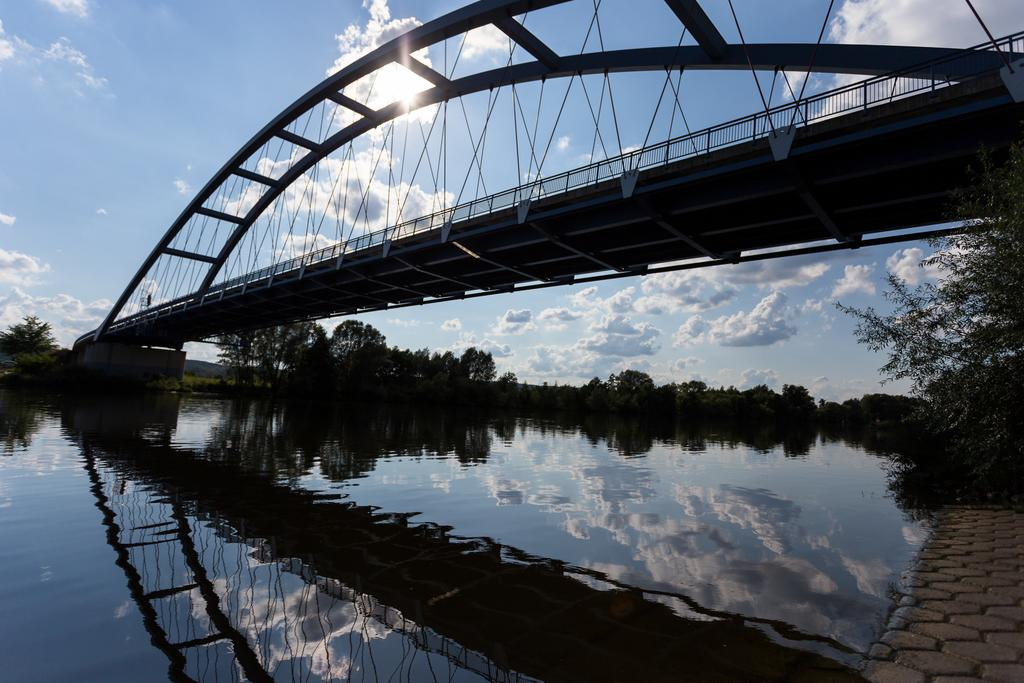What structure can be seen in the picture? There is a bridge in the picture. What natural element is visible in the picture? There is water visible in the picture. What type of vegetation is present in the picture? There are trees in the picture. What can be seen in the background of the picture? The sun and the sky are visible in the background of the picture. How many grapes are hanging from the bridge in the image? There are no grapes present in the image, as it features a bridge, water, trees, and a sky background. 